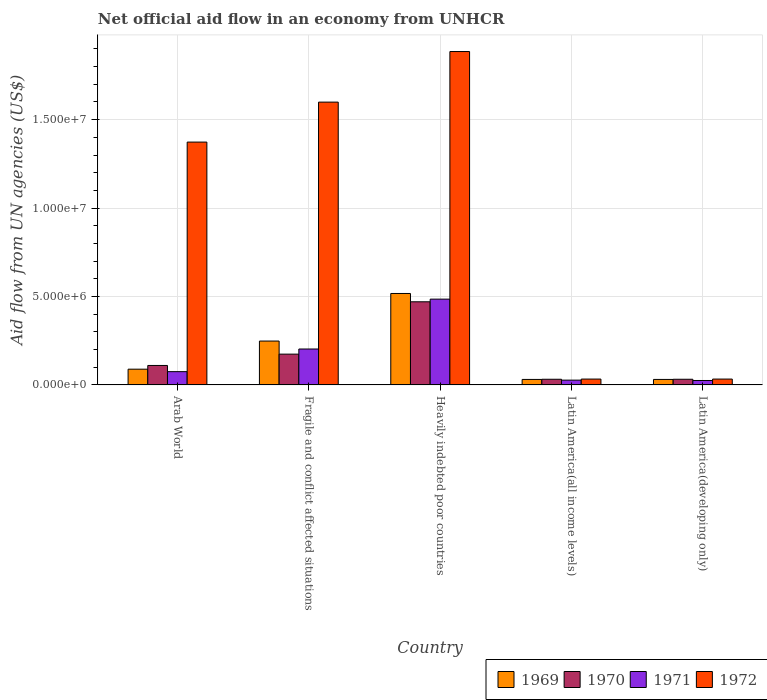How many different coloured bars are there?
Make the answer very short. 4. What is the label of the 1st group of bars from the left?
Give a very brief answer. Arab World. What is the net official aid flow in 1972 in Latin America(all income levels)?
Provide a short and direct response. 3.30e+05. Across all countries, what is the maximum net official aid flow in 1969?
Offer a very short reply. 5.17e+06. Across all countries, what is the minimum net official aid flow in 1972?
Provide a succinct answer. 3.30e+05. In which country was the net official aid flow in 1971 maximum?
Provide a short and direct response. Heavily indebted poor countries. In which country was the net official aid flow in 1971 minimum?
Ensure brevity in your answer.  Latin America(developing only). What is the total net official aid flow in 1972 in the graph?
Offer a very short reply. 4.92e+07. What is the difference between the net official aid flow in 1971 in Fragile and conflict affected situations and that in Latin America(all income levels)?
Ensure brevity in your answer.  1.76e+06. What is the difference between the net official aid flow in 1969 in Latin America(developing only) and the net official aid flow in 1971 in Heavily indebted poor countries?
Your response must be concise. -4.54e+06. What is the average net official aid flow in 1972 per country?
Your response must be concise. 9.85e+06. In how many countries, is the net official aid flow in 1972 greater than 12000000 US$?
Provide a succinct answer. 3. What is the ratio of the net official aid flow in 1970 in Arab World to that in Latin America(developing only)?
Offer a very short reply. 3.44. Is the difference between the net official aid flow in 1971 in Heavily indebted poor countries and Latin America(developing only) greater than the difference between the net official aid flow in 1970 in Heavily indebted poor countries and Latin America(developing only)?
Your answer should be very brief. Yes. What is the difference between the highest and the second highest net official aid flow in 1971?
Keep it short and to the point. 4.10e+06. What is the difference between the highest and the lowest net official aid flow in 1969?
Provide a succinct answer. 4.86e+06. Is the sum of the net official aid flow in 1972 in Arab World and Latin America(developing only) greater than the maximum net official aid flow in 1969 across all countries?
Keep it short and to the point. Yes. What does the 3rd bar from the left in Latin America(developing only) represents?
Offer a very short reply. 1971. Is it the case that in every country, the sum of the net official aid flow in 1970 and net official aid flow in 1969 is greater than the net official aid flow in 1972?
Provide a succinct answer. No. Are all the bars in the graph horizontal?
Provide a short and direct response. No. How many countries are there in the graph?
Make the answer very short. 5. Does the graph contain grids?
Offer a very short reply. Yes. Where does the legend appear in the graph?
Make the answer very short. Bottom right. What is the title of the graph?
Make the answer very short. Net official aid flow in an economy from UNHCR. Does "1962" appear as one of the legend labels in the graph?
Your answer should be compact. No. What is the label or title of the Y-axis?
Give a very brief answer. Aid flow from UN agencies (US$). What is the Aid flow from UN agencies (US$) in 1969 in Arab World?
Ensure brevity in your answer.  8.90e+05. What is the Aid flow from UN agencies (US$) of 1970 in Arab World?
Your response must be concise. 1.10e+06. What is the Aid flow from UN agencies (US$) in 1971 in Arab World?
Make the answer very short. 7.50e+05. What is the Aid flow from UN agencies (US$) in 1972 in Arab World?
Offer a terse response. 1.37e+07. What is the Aid flow from UN agencies (US$) in 1969 in Fragile and conflict affected situations?
Your response must be concise. 2.48e+06. What is the Aid flow from UN agencies (US$) in 1970 in Fragile and conflict affected situations?
Your answer should be compact. 1.74e+06. What is the Aid flow from UN agencies (US$) of 1971 in Fragile and conflict affected situations?
Offer a terse response. 2.03e+06. What is the Aid flow from UN agencies (US$) of 1972 in Fragile and conflict affected situations?
Your response must be concise. 1.60e+07. What is the Aid flow from UN agencies (US$) of 1969 in Heavily indebted poor countries?
Ensure brevity in your answer.  5.17e+06. What is the Aid flow from UN agencies (US$) in 1970 in Heavily indebted poor countries?
Make the answer very short. 4.70e+06. What is the Aid flow from UN agencies (US$) of 1971 in Heavily indebted poor countries?
Ensure brevity in your answer.  4.85e+06. What is the Aid flow from UN agencies (US$) of 1972 in Heavily indebted poor countries?
Your answer should be very brief. 1.88e+07. What is the Aid flow from UN agencies (US$) of 1969 in Latin America(all income levels)?
Your answer should be very brief. 3.10e+05. What is the Aid flow from UN agencies (US$) of 1969 in Latin America(developing only)?
Give a very brief answer. 3.10e+05. What is the Aid flow from UN agencies (US$) of 1972 in Latin America(developing only)?
Keep it short and to the point. 3.30e+05. Across all countries, what is the maximum Aid flow from UN agencies (US$) in 1969?
Offer a very short reply. 5.17e+06. Across all countries, what is the maximum Aid flow from UN agencies (US$) of 1970?
Make the answer very short. 4.70e+06. Across all countries, what is the maximum Aid flow from UN agencies (US$) in 1971?
Provide a short and direct response. 4.85e+06. Across all countries, what is the maximum Aid flow from UN agencies (US$) in 1972?
Provide a succinct answer. 1.88e+07. Across all countries, what is the minimum Aid flow from UN agencies (US$) of 1969?
Ensure brevity in your answer.  3.10e+05. Across all countries, what is the minimum Aid flow from UN agencies (US$) in 1970?
Keep it short and to the point. 3.20e+05. Across all countries, what is the minimum Aid flow from UN agencies (US$) of 1971?
Give a very brief answer. 2.50e+05. Across all countries, what is the minimum Aid flow from UN agencies (US$) of 1972?
Provide a short and direct response. 3.30e+05. What is the total Aid flow from UN agencies (US$) in 1969 in the graph?
Ensure brevity in your answer.  9.16e+06. What is the total Aid flow from UN agencies (US$) in 1970 in the graph?
Offer a very short reply. 8.18e+06. What is the total Aid flow from UN agencies (US$) in 1971 in the graph?
Your answer should be compact. 8.15e+06. What is the total Aid flow from UN agencies (US$) in 1972 in the graph?
Offer a terse response. 4.92e+07. What is the difference between the Aid flow from UN agencies (US$) of 1969 in Arab World and that in Fragile and conflict affected situations?
Make the answer very short. -1.59e+06. What is the difference between the Aid flow from UN agencies (US$) of 1970 in Arab World and that in Fragile and conflict affected situations?
Your answer should be very brief. -6.40e+05. What is the difference between the Aid flow from UN agencies (US$) of 1971 in Arab World and that in Fragile and conflict affected situations?
Your answer should be very brief. -1.28e+06. What is the difference between the Aid flow from UN agencies (US$) of 1972 in Arab World and that in Fragile and conflict affected situations?
Offer a terse response. -2.26e+06. What is the difference between the Aid flow from UN agencies (US$) of 1969 in Arab World and that in Heavily indebted poor countries?
Offer a very short reply. -4.28e+06. What is the difference between the Aid flow from UN agencies (US$) in 1970 in Arab World and that in Heavily indebted poor countries?
Offer a terse response. -3.60e+06. What is the difference between the Aid flow from UN agencies (US$) in 1971 in Arab World and that in Heavily indebted poor countries?
Keep it short and to the point. -4.10e+06. What is the difference between the Aid flow from UN agencies (US$) in 1972 in Arab World and that in Heavily indebted poor countries?
Offer a terse response. -5.12e+06. What is the difference between the Aid flow from UN agencies (US$) in 1969 in Arab World and that in Latin America(all income levels)?
Your response must be concise. 5.80e+05. What is the difference between the Aid flow from UN agencies (US$) of 1970 in Arab World and that in Latin America(all income levels)?
Make the answer very short. 7.80e+05. What is the difference between the Aid flow from UN agencies (US$) of 1972 in Arab World and that in Latin America(all income levels)?
Offer a very short reply. 1.34e+07. What is the difference between the Aid flow from UN agencies (US$) of 1969 in Arab World and that in Latin America(developing only)?
Your response must be concise. 5.80e+05. What is the difference between the Aid flow from UN agencies (US$) in 1970 in Arab World and that in Latin America(developing only)?
Your answer should be compact. 7.80e+05. What is the difference between the Aid flow from UN agencies (US$) in 1971 in Arab World and that in Latin America(developing only)?
Make the answer very short. 5.00e+05. What is the difference between the Aid flow from UN agencies (US$) of 1972 in Arab World and that in Latin America(developing only)?
Offer a terse response. 1.34e+07. What is the difference between the Aid flow from UN agencies (US$) of 1969 in Fragile and conflict affected situations and that in Heavily indebted poor countries?
Your answer should be compact. -2.69e+06. What is the difference between the Aid flow from UN agencies (US$) in 1970 in Fragile and conflict affected situations and that in Heavily indebted poor countries?
Make the answer very short. -2.96e+06. What is the difference between the Aid flow from UN agencies (US$) of 1971 in Fragile and conflict affected situations and that in Heavily indebted poor countries?
Your answer should be very brief. -2.82e+06. What is the difference between the Aid flow from UN agencies (US$) in 1972 in Fragile and conflict affected situations and that in Heavily indebted poor countries?
Offer a very short reply. -2.86e+06. What is the difference between the Aid flow from UN agencies (US$) of 1969 in Fragile and conflict affected situations and that in Latin America(all income levels)?
Your response must be concise. 2.17e+06. What is the difference between the Aid flow from UN agencies (US$) in 1970 in Fragile and conflict affected situations and that in Latin America(all income levels)?
Offer a terse response. 1.42e+06. What is the difference between the Aid flow from UN agencies (US$) of 1971 in Fragile and conflict affected situations and that in Latin America(all income levels)?
Offer a very short reply. 1.76e+06. What is the difference between the Aid flow from UN agencies (US$) of 1972 in Fragile and conflict affected situations and that in Latin America(all income levels)?
Your answer should be compact. 1.57e+07. What is the difference between the Aid flow from UN agencies (US$) of 1969 in Fragile and conflict affected situations and that in Latin America(developing only)?
Provide a short and direct response. 2.17e+06. What is the difference between the Aid flow from UN agencies (US$) in 1970 in Fragile and conflict affected situations and that in Latin America(developing only)?
Provide a short and direct response. 1.42e+06. What is the difference between the Aid flow from UN agencies (US$) in 1971 in Fragile and conflict affected situations and that in Latin America(developing only)?
Give a very brief answer. 1.78e+06. What is the difference between the Aid flow from UN agencies (US$) in 1972 in Fragile and conflict affected situations and that in Latin America(developing only)?
Keep it short and to the point. 1.57e+07. What is the difference between the Aid flow from UN agencies (US$) in 1969 in Heavily indebted poor countries and that in Latin America(all income levels)?
Provide a succinct answer. 4.86e+06. What is the difference between the Aid flow from UN agencies (US$) in 1970 in Heavily indebted poor countries and that in Latin America(all income levels)?
Make the answer very short. 4.38e+06. What is the difference between the Aid flow from UN agencies (US$) of 1971 in Heavily indebted poor countries and that in Latin America(all income levels)?
Keep it short and to the point. 4.58e+06. What is the difference between the Aid flow from UN agencies (US$) of 1972 in Heavily indebted poor countries and that in Latin America(all income levels)?
Offer a terse response. 1.85e+07. What is the difference between the Aid flow from UN agencies (US$) in 1969 in Heavily indebted poor countries and that in Latin America(developing only)?
Keep it short and to the point. 4.86e+06. What is the difference between the Aid flow from UN agencies (US$) in 1970 in Heavily indebted poor countries and that in Latin America(developing only)?
Provide a succinct answer. 4.38e+06. What is the difference between the Aid flow from UN agencies (US$) in 1971 in Heavily indebted poor countries and that in Latin America(developing only)?
Give a very brief answer. 4.60e+06. What is the difference between the Aid flow from UN agencies (US$) of 1972 in Heavily indebted poor countries and that in Latin America(developing only)?
Offer a terse response. 1.85e+07. What is the difference between the Aid flow from UN agencies (US$) of 1970 in Latin America(all income levels) and that in Latin America(developing only)?
Your answer should be very brief. 0. What is the difference between the Aid flow from UN agencies (US$) in 1971 in Latin America(all income levels) and that in Latin America(developing only)?
Provide a short and direct response. 2.00e+04. What is the difference between the Aid flow from UN agencies (US$) of 1972 in Latin America(all income levels) and that in Latin America(developing only)?
Ensure brevity in your answer.  0. What is the difference between the Aid flow from UN agencies (US$) in 1969 in Arab World and the Aid flow from UN agencies (US$) in 1970 in Fragile and conflict affected situations?
Your response must be concise. -8.50e+05. What is the difference between the Aid flow from UN agencies (US$) in 1969 in Arab World and the Aid flow from UN agencies (US$) in 1971 in Fragile and conflict affected situations?
Your answer should be compact. -1.14e+06. What is the difference between the Aid flow from UN agencies (US$) in 1969 in Arab World and the Aid flow from UN agencies (US$) in 1972 in Fragile and conflict affected situations?
Your answer should be compact. -1.51e+07. What is the difference between the Aid flow from UN agencies (US$) in 1970 in Arab World and the Aid flow from UN agencies (US$) in 1971 in Fragile and conflict affected situations?
Make the answer very short. -9.30e+05. What is the difference between the Aid flow from UN agencies (US$) of 1970 in Arab World and the Aid flow from UN agencies (US$) of 1972 in Fragile and conflict affected situations?
Ensure brevity in your answer.  -1.49e+07. What is the difference between the Aid flow from UN agencies (US$) in 1971 in Arab World and the Aid flow from UN agencies (US$) in 1972 in Fragile and conflict affected situations?
Make the answer very short. -1.52e+07. What is the difference between the Aid flow from UN agencies (US$) in 1969 in Arab World and the Aid flow from UN agencies (US$) in 1970 in Heavily indebted poor countries?
Your answer should be very brief. -3.81e+06. What is the difference between the Aid flow from UN agencies (US$) of 1969 in Arab World and the Aid flow from UN agencies (US$) of 1971 in Heavily indebted poor countries?
Provide a short and direct response. -3.96e+06. What is the difference between the Aid flow from UN agencies (US$) of 1969 in Arab World and the Aid flow from UN agencies (US$) of 1972 in Heavily indebted poor countries?
Make the answer very short. -1.80e+07. What is the difference between the Aid flow from UN agencies (US$) of 1970 in Arab World and the Aid flow from UN agencies (US$) of 1971 in Heavily indebted poor countries?
Your answer should be compact. -3.75e+06. What is the difference between the Aid flow from UN agencies (US$) of 1970 in Arab World and the Aid flow from UN agencies (US$) of 1972 in Heavily indebted poor countries?
Give a very brief answer. -1.78e+07. What is the difference between the Aid flow from UN agencies (US$) of 1971 in Arab World and the Aid flow from UN agencies (US$) of 1972 in Heavily indebted poor countries?
Give a very brief answer. -1.81e+07. What is the difference between the Aid flow from UN agencies (US$) in 1969 in Arab World and the Aid flow from UN agencies (US$) in 1970 in Latin America(all income levels)?
Give a very brief answer. 5.70e+05. What is the difference between the Aid flow from UN agencies (US$) of 1969 in Arab World and the Aid flow from UN agencies (US$) of 1971 in Latin America(all income levels)?
Your answer should be very brief. 6.20e+05. What is the difference between the Aid flow from UN agencies (US$) in 1969 in Arab World and the Aid flow from UN agencies (US$) in 1972 in Latin America(all income levels)?
Keep it short and to the point. 5.60e+05. What is the difference between the Aid flow from UN agencies (US$) of 1970 in Arab World and the Aid flow from UN agencies (US$) of 1971 in Latin America(all income levels)?
Provide a succinct answer. 8.30e+05. What is the difference between the Aid flow from UN agencies (US$) in 1970 in Arab World and the Aid flow from UN agencies (US$) in 1972 in Latin America(all income levels)?
Your response must be concise. 7.70e+05. What is the difference between the Aid flow from UN agencies (US$) of 1969 in Arab World and the Aid flow from UN agencies (US$) of 1970 in Latin America(developing only)?
Offer a very short reply. 5.70e+05. What is the difference between the Aid flow from UN agencies (US$) in 1969 in Arab World and the Aid flow from UN agencies (US$) in 1971 in Latin America(developing only)?
Keep it short and to the point. 6.40e+05. What is the difference between the Aid flow from UN agencies (US$) in 1969 in Arab World and the Aid flow from UN agencies (US$) in 1972 in Latin America(developing only)?
Offer a terse response. 5.60e+05. What is the difference between the Aid flow from UN agencies (US$) in 1970 in Arab World and the Aid flow from UN agencies (US$) in 1971 in Latin America(developing only)?
Make the answer very short. 8.50e+05. What is the difference between the Aid flow from UN agencies (US$) in 1970 in Arab World and the Aid flow from UN agencies (US$) in 1972 in Latin America(developing only)?
Your answer should be very brief. 7.70e+05. What is the difference between the Aid flow from UN agencies (US$) in 1971 in Arab World and the Aid flow from UN agencies (US$) in 1972 in Latin America(developing only)?
Offer a very short reply. 4.20e+05. What is the difference between the Aid flow from UN agencies (US$) of 1969 in Fragile and conflict affected situations and the Aid flow from UN agencies (US$) of 1970 in Heavily indebted poor countries?
Give a very brief answer. -2.22e+06. What is the difference between the Aid flow from UN agencies (US$) in 1969 in Fragile and conflict affected situations and the Aid flow from UN agencies (US$) in 1971 in Heavily indebted poor countries?
Make the answer very short. -2.37e+06. What is the difference between the Aid flow from UN agencies (US$) of 1969 in Fragile and conflict affected situations and the Aid flow from UN agencies (US$) of 1972 in Heavily indebted poor countries?
Offer a very short reply. -1.64e+07. What is the difference between the Aid flow from UN agencies (US$) of 1970 in Fragile and conflict affected situations and the Aid flow from UN agencies (US$) of 1971 in Heavily indebted poor countries?
Your answer should be very brief. -3.11e+06. What is the difference between the Aid flow from UN agencies (US$) of 1970 in Fragile and conflict affected situations and the Aid flow from UN agencies (US$) of 1972 in Heavily indebted poor countries?
Ensure brevity in your answer.  -1.71e+07. What is the difference between the Aid flow from UN agencies (US$) of 1971 in Fragile and conflict affected situations and the Aid flow from UN agencies (US$) of 1972 in Heavily indebted poor countries?
Make the answer very short. -1.68e+07. What is the difference between the Aid flow from UN agencies (US$) of 1969 in Fragile and conflict affected situations and the Aid flow from UN agencies (US$) of 1970 in Latin America(all income levels)?
Your response must be concise. 2.16e+06. What is the difference between the Aid flow from UN agencies (US$) in 1969 in Fragile and conflict affected situations and the Aid flow from UN agencies (US$) in 1971 in Latin America(all income levels)?
Give a very brief answer. 2.21e+06. What is the difference between the Aid flow from UN agencies (US$) in 1969 in Fragile and conflict affected situations and the Aid flow from UN agencies (US$) in 1972 in Latin America(all income levels)?
Your response must be concise. 2.15e+06. What is the difference between the Aid flow from UN agencies (US$) of 1970 in Fragile and conflict affected situations and the Aid flow from UN agencies (US$) of 1971 in Latin America(all income levels)?
Offer a terse response. 1.47e+06. What is the difference between the Aid flow from UN agencies (US$) of 1970 in Fragile and conflict affected situations and the Aid flow from UN agencies (US$) of 1972 in Latin America(all income levels)?
Provide a succinct answer. 1.41e+06. What is the difference between the Aid flow from UN agencies (US$) in 1971 in Fragile and conflict affected situations and the Aid flow from UN agencies (US$) in 1972 in Latin America(all income levels)?
Keep it short and to the point. 1.70e+06. What is the difference between the Aid flow from UN agencies (US$) of 1969 in Fragile and conflict affected situations and the Aid flow from UN agencies (US$) of 1970 in Latin America(developing only)?
Provide a short and direct response. 2.16e+06. What is the difference between the Aid flow from UN agencies (US$) of 1969 in Fragile and conflict affected situations and the Aid flow from UN agencies (US$) of 1971 in Latin America(developing only)?
Ensure brevity in your answer.  2.23e+06. What is the difference between the Aid flow from UN agencies (US$) in 1969 in Fragile and conflict affected situations and the Aid flow from UN agencies (US$) in 1972 in Latin America(developing only)?
Ensure brevity in your answer.  2.15e+06. What is the difference between the Aid flow from UN agencies (US$) of 1970 in Fragile and conflict affected situations and the Aid flow from UN agencies (US$) of 1971 in Latin America(developing only)?
Offer a terse response. 1.49e+06. What is the difference between the Aid flow from UN agencies (US$) in 1970 in Fragile and conflict affected situations and the Aid flow from UN agencies (US$) in 1972 in Latin America(developing only)?
Give a very brief answer. 1.41e+06. What is the difference between the Aid flow from UN agencies (US$) of 1971 in Fragile and conflict affected situations and the Aid flow from UN agencies (US$) of 1972 in Latin America(developing only)?
Your answer should be very brief. 1.70e+06. What is the difference between the Aid flow from UN agencies (US$) in 1969 in Heavily indebted poor countries and the Aid flow from UN agencies (US$) in 1970 in Latin America(all income levels)?
Provide a short and direct response. 4.85e+06. What is the difference between the Aid flow from UN agencies (US$) of 1969 in Heavily indebted poor countries and the Aid flow from UN agencies (US$) of 1971 in Latin America(all income levels)?
Give a very brief answer. 4.90e+06. What is the difference between the Aid flow from UN agencies (US$) in 1969 in Heavily indebted poor countries and the Aid flow from UN agencies (US$) in 1972 in Latin America(all income levels)?
Your answer should be compact. 4.84e+06. What is the difference between the Aid flow from UN agencies (US$) in 1970 in Heavily indebted poor countries and the Aid flow from UN agencies (US$) in 1971 in Latin America(all income levels)?
Offer a very short reply. 4.43e+06. What is the difference between the Aid flow from UN agencies (US$) in 1970 in Heavily indebted poor countries and the Aid flow from UN agencies (US$) in 1972 in Latin America(all income levels)?
Give a very brief answer. 4.37e+06. What is the difference between the Aid flow from UN agencies (US$) of 1971 in Heavily indebted poor countries and the Aid flow from UN agencies (US$) of 1972 in Latin America(all income levels)?
Provide a short and direct response. 4.52e+06. What is the difference between the Aid flow from UN agencies (US$) of 1969 in Heavily indebted poor countries and the Aid flow from UN agencies (US$) of 1970 in Latin America(developing only)?
Your response must be concise. 4.85e+06. What is the difference between the Aid flow from UN agencies (US$) in 1969 in Heavily indebted poor countries and the Aid flow from UN agencies (US$) in 1971 in Latin America(developing only)?
Your answer should be compact. 4.92e+06. What is the difference between the Aid flow from UN agencies (US$) in 1969 in Heavily indebted poor countries and the Aid flow from UN agencies (US$) in 1972 in Latin America(developing only)?
Your response must be concise. 4.84e+06. What is the difference between the Aid flow from UN agencies (US$) in 1970 in Heavily indebted poor countries and the Aid flow from UN agencies (US$) in 1971 in Latin America(developing only)?
Give a very brief answer. 4.45e+06. What is the difference between the Aid flow from UN agencies (US$) of 1970 in Heavily indebted poor countries and the Aid flow from UN agencies (US$) of 1972 in Latin America(developing only)?
Offer a terse response. 4.37e+06. What is the difference between the Aid flow from UN agencies (US$) of 1971 in Heavily indebted poor countries and the Aid flow from UN agencies (US$) of 1972 in Latin America(developing only)?
Offer a terse response. 4.52e+06. What is the difference between the Aid flow from UN agencies (US$) of 1969 in Latin America(all income levels) and the Aid flow from UN agencies (US$) of 1970 in Latin America(developing only)?
Offer a very short reply. -10000. What is the difference between the Aid flow from UN agencies (US$) in 1969 in Latin America(all income levels) and the Aid flow from UN agencies (US$) in 1971 in Latin America(developing only)?
Provide a succinct answer. 6.00e+04. What is the difference between the Aid flow from UN agencies (US$) of 1969 in Latin America(all income levels) and the Aid flow from UN agencies (US$) of 1972 in Latin America(developing only)?
Provide a succinct answer. -2.00e+04. What is the difference between the Aid flow from UN agencies (US$) in 1970 in Latin America(all income levels) and the Aid flow from UN agencies (US$) in 1971 in Latin America(developing only)?
Provide a short and direct response. 7.00e+04. What is the difference between the Aid flow from UN agencies (US$) in 1970 in Latin America(all income levels) and the Aid flow from UN agencies (US$) in 1972 in Latin America(developing only)?
Make the answer very short. -10000. What is the average Aid flow from UN agencies (US$) in 1969 per country?
Your response must be concise. 1.83e+06. What is the average Aid flow from UN agencies (US$) in 1970 per country?
Provide a short and direct response. 1.64e+06. What is the average Aid flow from UN agencies (US$) of 1971 per country?
Provide a succinct answer. 1.63e+06. What is the average Aid flow from UN agencies (US$) of 1972 per country?
Your response must be concise. 9.85e+06. What is the difference between the Aid flow from UN agencies (US$) of 1969 and Aid flow from UN agencies (US$) of 1971 in Arab World?
Offer a terse response. 1.40e+05. What is the difference between the Aid flow from UN agencies (US$) of 1969 and Aid flow from UN agencies (US$) of 1972 in Arab World?
Your answer should be compact. -1.28e+07. What is the difference between the Aid flow from UN agencies (US$) of 1970 and Aid flow from UN agencies (US$) of 1972 in Arab World?
Ensure brevity in your answer.  -1.26e+07. What is the difference between the Aid flow from UN agencies (US$) of 1971 and Aid flow from UN agencies (US$) of 1972 in Arab World?
Provide a succinct answer. -1.30e+07. What is the difference between the Aid flow from UN agencies (US$) in 1969 and Aid flow from UN agencies (US$) in 1970 in Fragile and conflict affected situations?
Your answer should be compact. 7.40e+05. What is the difference between the Aid flow from UN agencies (US$) in 1969 and Aid flow from UN agencies (US$) in 1971 in Fragile and conflict affected situations?
Keep it short and to the point. 4.50e+05. What is the difference between the Aid flow from UN agencies (US$) of 1969 and Aid flow from UN agencies (US$) of 1972 in Fragile and conflict affected situations?
Provide a succinct answer. -1.35e+07. What is the difference between the Aid flow from UN agencies (US$) of 1970 and Aid flow from UN agencies (US$) of 1971 in Fragile and conflict affected situations?
Make the answer very short. -2.90e+05. What is the difference between the Aid flow from UN agencies (US$) in 1970 and Aid flow from UN agencies (US$) in 1972 in Fragile and conflict affected situations?
Make the answer very short. -1.42e+07. What is the difference between the Aid flow from UN agencies (US$) of 1971 and Aid flow from UN agencies (US$) of 1972 in Fragile and conflict affected situations?
Offer a very short reply. -1.40e+07. What is the difference between the Aid flow from UN agencies (US$) in 1969 and Aid flow from UN agencies (US$) in 1972 in Heavily indebted poor countries?
Offer a terse response. -1.37e+07. What is the difference between the Aid flow from UN agencies (US$) in 1970 and Aid flow from UN agencies (US$) in 1972 in Heavily indebted poor countries?
Your response must be concise. -1.42e+07. What is the difference between the Aid flow from UN agencies (US$) of 1971 and Aid flow from UN agencies (US$) of 1972 in Heavily indebted poor countries?
Offer a very short reply. -1.40e+07. What is the difference between the Aid flow from UN agencies (US$) in 1969 and Aid flow from UN agencies (US$) in 1971 in Latin America(all income levels)?
Keep it short and to the point. 4.00e+04. What is the difference between the Aid flow from UN agencies (US$) of 1969 and Aid flow from UN agencies (US$) of 1972 in Latin America(all income levels)?
Your answer should be very brief. -2.00e+04. What is the difference between the Aid flow from UN agencies (US$) of 1970 and Aid flow from UN agencies (US$) of 1972 in Latin America(all income levels)?
Provide a succinct answer. -10000. What is the difference between the Aid flow from UN agencies (US$) in 1971 and Aid flow from UN agencies (US$) in 1972 in Latin America(all income levels)?
Ensure brevity in your answer.  -6.00e+04. What is the difference between the Aid flow from UN agencies (US$) in 1969 and Aid flow from UN agencies (US$) in 1970 in Latin America(developing only)?
Your response must be concise. -10000. What is the difference between the Aid flow from UN agencies (US$) in 1969 and Aid flow from UN agencies (US$) in 1971 in Latin America(developing only)?
Provide a short and direct response. 6.00e+04. What is the difference between the Aid flow from UN agencies (US$) in 1970 and Aid flow from UN agencies (US$) in 1971 in Latin America(developing only)?
Make the answer very short. 7.00e+04. What is the difference between the Aid flow from UN agencies (US$) in 1971 and Aid flow from UN agencies (US$) in 1972 in Latin America(developing only)?
Your response must be concise. -8.00e+04. What is the ratio of the Aid flow from UN agencies (US$) of 1969 in Arab World to that in Fragile and conflict affected situations?
Keep it short and to the point. 0.36. What is the ratio of the Aid flow from UN agencies (US$) in 1970 in Arab World to that in Fragile and conflict affected situations?
Provide a short and direct response. 0.63. What is the ratio of the Aid flow from UN agencies (US$) in 1971 in Arab World to that in Fragile and conflict affected situations?
Offer a terse response. 0.37. What is the ratio of the Aid flow from UN agencies (US$) of 1972 in Arab World to that in Fragile and conflict affected situations?
Offer a very short reply. 0.86. What is the ratio of the Aid flow from UN agencies (US$) of 1969 in Arab World to that in Heavily indebted poor countries?
Offer a very short reply. 0.17. What is the ratio of the Aid flow from UN agencies (US$) in 1970 in Arab World to that in Heavily indebted poor countries?
Offer a terse response. 0.23. What is the ratio of the Aid flow from UN agencies (US$) in 1971 in Arab World to that in Heavily indebted poor countries?
Offer a terse response. 0.15. What is the ratio of the Aid flow from UN agencies (US$) of 1972 in Arab World to that in Heavily indebted poor countries?
Give a very brief answer. 0.73. What is the ratio of the Aid flow from UN agencies (US$) of 1969 in Arab World to that in Latin America(all income levels)?
Make the answer very short. 2.87. What is the ratio of the Aid flow from UN agencies (US$) of 1970 in Arab World to that in Latin America(all income levels)?
Provide a succinct answer. 3.44. What is the ratio of the Aid flow from UN agencies (US$) in 1971 in Arab World to that in Latin America(all income levels)?
Make the answer very short. 2.78. What is the ratio of the Aid flow from UN agencies (US$) in 1972 in Arab World to that in Latin America(all income levels)?
Keep it short and to the point. 41.61. What is the ratio of the Aid flow from UN agencies (US$) in 1969 in Arab World to that in Latin America(developing only)?
Keep it short and to the point. 2.87. What is the ratio of the Aid flow from UN agencies (US$) of 1970 in Arab World to that in Latin America(developing only)?
Offer a very short reply. 3.44. What is the ratio of the Aid flow from UN agencies (US$) of 1971 in Arab World to that in Latin America(developing only)?
Offer a terse response. 3. What is the ratio of the Aid flow from UN agencies (US$) in 1972 in Arab World to that in Latin America(developing only)?
Provide a succinct answer. 41.61. What is the ratio of the Aid flow from UN agencies (US$) in 1969 in Fragile and conflict affected situations to that in Heavily indebted poor countries?
Your response must be concise. 0.48. What is the ratio of the Aid flow from UN agencies (US$) in 1970 in Fragile and conflict affected situations to that in Heavily indebted poor countries?
Your answer should be very brief. 0.37. What is the ratio of the Aid flow from UN agencies (US$) in 1971 in Fragile and conflict affected situations to that in Heavily indebted poor countries?
Give a very brief answer. 0.42. What is the ratio of the Aid flow from UN agencies (US$) of 1972 in Fragile and conflict affected situations to that in Heavily indebted poor countries?
Provide a short and direct response. 0.85. What is the ratio of the Aid flow from UN agencies (US$) of 1970 in Fragile and conflict affected situations to that in Latin America(all income levels)?
Your response must be concise. 5.44. What is the ratio of the Aid flow from UN agencies (US$) in 1971 in Fragile and conflict affected situations to that in Latin America(all income levels)?
Offer a very short reply. 7.52. What is the ratio of the Aid flow from UN agencies (US$) of 1972 in Fragile and conflict affected situations to that in Latin America(all income levels)?
Ensure brevity in your answer.  48.45. What is the ratio of the Aid flow from UN agencies (US$) in 1969 in Fragile and conflict affected situations to that in Latin America(developing only)?
Your answer should be compact. 8. What is the ratio of the Aid flow from UN agencies (US$) in 1970 in Fragile and conflict affected situations to that in Latin America(developing only)?
Make the answer very short. 5.44. What is the ratio of the Aid flow from UN agencies (US$) of 1971 in Fragile and conflict affected situations to that in Latin America(developing only)?
Keep it short and to the point. 8.12. What is the ratio of the Aid flow from UN agencies (US$) in 1972 in Fragile and conflict affected situations to that in Latin America(developing only)?
Keep it short and to the point. 48.45. What is the ratio of the Aid flow from UN agencies (US$) of 1969 in Heavily indebted poor countries to that in Latin America(all income levels)?
Your answer should be compact. 16.68. What is the ratio of the Aid flow from UN agencies (US$) of 1970 in Heavily indebted poor countries to that in Latin America(all income levels)?
Offer a very short reply. 14.69. What is the ratio of the Aid flow from UN agencies (US$) of 1971 in Heavily indebted poor countries to that in Latin America(all income levels)?
Offer a very short reply. 17.96. What is the ratio of the Aid flow from UN agencies (US$) of 1972 in Heavily indebted poor countries to that in Latin America(all income levels)?
Offer a terse response. 57.12. What is the ratio of the Aid flow from UN agencies (US$) in 1969 in Heavily indebted poor countries to that in Latin America(developing only)?
Ensure brevity in your answer.  16.68. What is the ratio of the Aid flow from UN agencies (US$) of 1970 in Heavily indebted poor countries to that in Latin America(developing only)?
Your response must be concise. 14.69. What is the ratio of the Aid flow from UN agencies (US$) of 1972 in Heavily indebted poor countries to that in Latin America(developing only)?
Your answer should be very brief. 57.12. What is the ratio of the Aid flow from UN agencies (US$) of 1969 in Latin America(all income levels) to that in Latin America(developing only)?
Provide a succinct answer. 1. What is the ratio of the Aid flow from UN agencies (US$) in 1971 in Latin America(all income levels) to that in Latin America(developing only)?
Keep it short and to the point. 1.08. What is the ratio of the Aid flow from UN agencies (US$) in 1972 in Latin America(all income levels) to that in Latin America(developing only)?
Make the answer very short. 1. What is the difference between the highest and the second highest Aid flow from UN agencies (US$) of 1969?
Your answer should be compact. 2.69e+06. What is the difference between the highest and the second highest Aid flow from UN agencies (US$) in 1970?
Your response must be concise. 2.96e+06. What is the difference between the highest and the second highest Aid flow from UN agencies (US$) in 1971?
Offer a terse response. 2.82e+06. What is the difference between the highest and the second highest Aid flow from UN agencies (US$) of 1972?
Offer a terse response. 2.86e+06. What is the difference between the highest and the lowest Aid flow from UN agencies (US$) in 1969?
Ensure brevity in your answer.  4.86e+06. What is the difference between the highest and the lowest Aid flow from UN agencies (US$) in 1970?
Make the answer very short. 4.38e+06. What is the difference between the highest and the lowest Aid flow from UN agencies (US$) in 1971?
Offer a terse response. 4.60e+06. What is the difference between the highest and the lowest Aid flow from UN agencies (US$) in 1972?
Offer a very short reply. 1.85e+07. 